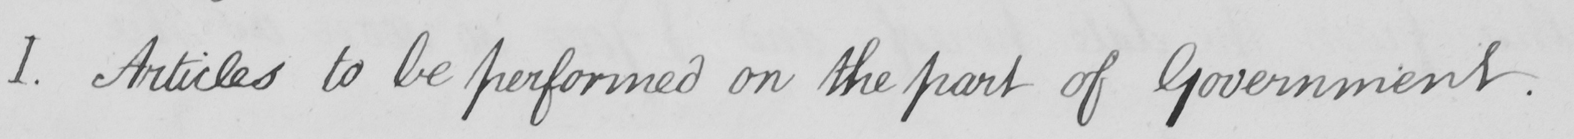Please transcribe the handwritten text in this image. I . Articles to be performed on the part of Government . 